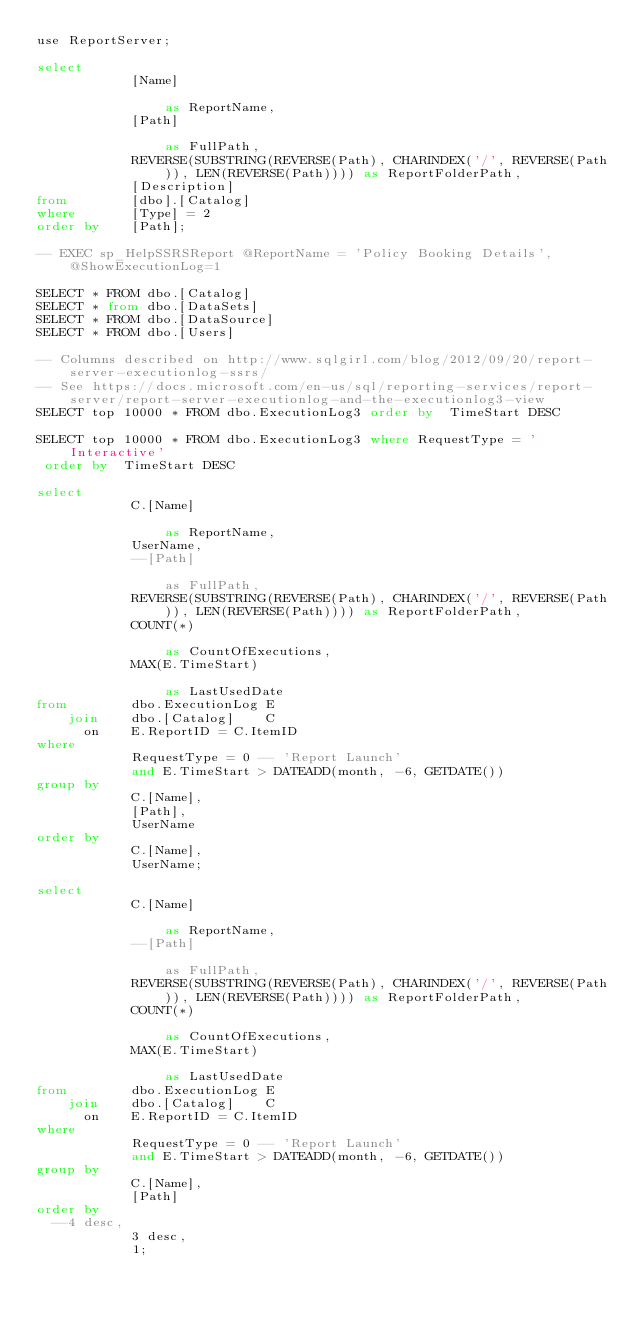Convert code to text. <code><loc_0><loc_0><loc_500><loc_500><_SQL_>use ReportServer;

select
            [Name]                                                                               as ReportName,
            [Path]                                                                               as FullPath,
            REVERSE(SUBSTRING(REVERSE(Path), CHARINDEX('/', REVERSE(Path)), LEN(REVERSE(Path)))) as ReportFolderPath,
            [Description]
from        [dbo].[Catalog]
where       [Type] = 2
order by    [Path];

-- EXEC sp_HelpSSRSReport @ReportName = 'Policy Booking Details', @ShowExecutionLog=1

SELECT * FROM dbo.[Catalog]
SELECT * from dbo.[DataSets]
SELECT * FROM dbo.[DataSource]
SELECT * FROM dbo.[Users]

-- Columns described on http://www.sqlgirl.com/blog/2012/09/20/report-server-executionlog-ssrs/
-- See https://docs.microsoft.com/en-us/sql/reporting-services/report-server/report-server-executionlog-and-the-executionlog3-view
SELECT top 10000 * FROM dbo.ExecutionLog3 order by  TimeStart DESC

SELECT top 10000 * FROM dbo.ExecutionLog3 where RequestType = 'Interactive'
 order by  TimeStart DESC

select
            C.[Name]                                                                             as ReportName,
            UserName,
            --[Path]                                                                               as FullPath,
            REVERSE(SUBSTRING(REVERSE(Path), CHARINDEX('/', REVERSE(Path)), LEN(REVERSE(Path)))) as ReportFolderPath,
            COUNT(*)                                                                             as CountOfExecutions,
            MAX(E.TimeStart)                                                                     as LastUsedDate
from        dbo.ExecutionLog E
    join    dbo.[Catalog]    C
      on    E.ReportID = C.ItemID
where
            RequestType = 0 -- 'Report Launch'
            and E.TimeStart > DATEADD(month, -6, GETDATE())
group by
            C.[Name],
            [Path],
            UserName
order by
            C.[Name],
            UserName;

select
            C.[Name]                                                                             as ReportName,
            --[Path]                                                                               as FullPath,
            REVERSE(SUBSTRING(REVERSE(Path), CHARINDEX('/', REVERSE(Path)), LEN(REVERSE(Path)))) as ReportFolderPath,
            COUNT(*)                                                                             as CountOfExecutions,
            MAX(E.TimeStart)                                                                     as LastUsedDate
from        dbo.ExecutionLog E
    join    dbo.[Catalog]    C
      on    E.ReportID = C.ItemID
where
            RequestType = 0 -- 'Report Launch'
            and E.TimeStart > DATEADD(month, -6, GETDATE())
group by
            C.[Name],
            [Path]
order by
	--4 desc,
            3 desc,
            1;
</code> 